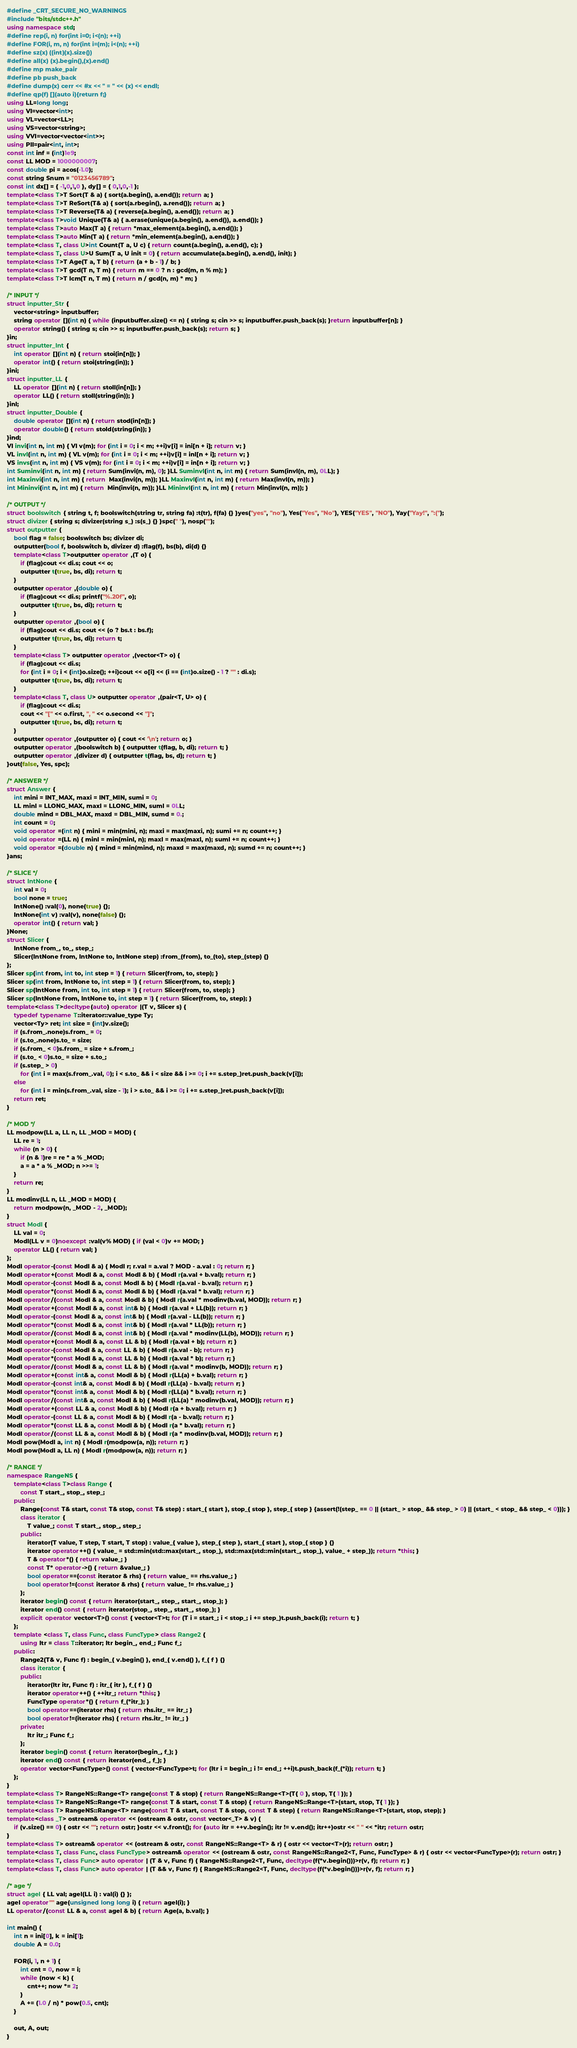<code> <loc_0><loc_0><loc_500><loc_500><_C++_>#define _CRT_SECURE_NO_WARNINGS
#include "bits/stdc++.h"
using namespace std;
#define rep(i, n) for(int i=0; i<(n); ++i)
#define FOR(i, m, n) for(int i=(m); i<(n); ++i)
#define sz(x) ((int)(x).size())
#define all(x) (x).begin(),(x).end()
#define mp make_pair
#define pb push_back
#define dump(x) cerr << #x << " = " << (x) << endl;
#define qp(f) [](auto i){return f;}
using LL=long long;
using VI=vector<int>;
using VL=vector<LL>;
using VS=vector<string>;
using VVI=vector<vector<int>>;
using PII=pair<int, int>;
const int inf = (int)1e9;
const LL MOD = 1000000007;
const double pi = acos(-1.0);
const string Snum = "0123456789";
const int dx[] = { -1,0,1,0 }, dy[] = { 0,1,0,-1 };
template<class T>T Sort(T & a) { sort(a.begin(), a.end()); return a; }
template<class T>T ReSort(T& a) { sort(a.rbegin(), a.rend()); return a; }
template<class T>T Reverse(T& a) { reverse(a.begin(), a.end()); return a; }
template<class T>void Unique(T& a) { a.erase(unique(a.begin(), a.end()), a.end()); }
template<class T>auto Max(T a) { return *max_element(a.begin(), a.end()); }
template<class T>auto Min(T a) { return *min_element(a.begin(), a.end()); }
template<class T, class U>int Count(T a, U c) { return count(a.begin(), a.end(), c); }
template<class T, class U>U Sum(T a, U init = 0) { return accumulate(a.begin(), a.end(), init); }
template<class T>T Age(T a, T b) { return (a + b - 1) / b; }
template<class T>T gcd(T n, T m) { return m == 0 ? n : gcd(m, n % m); }
template<class T>T lcm(T n, T m) { return n / gcd(n, m) * m; }

/* INPUT */
struct inputter_Str {
	vector<string> inputbuffer;
	string operator [](int n) { while (inputbuffer.size() <= n) { string s; cin >> s; inputbuffer.push_back(s); }return inputbuffer[n]; }
	operator string() { string s; cin >> s; inputbuffer.push_back(s); return s; }
}in;
struct inputter_Int {
	int operator [](int n) { return stoi(in[n]); }
	operator int() { return stoi(string(in)); }
}ini;
struct inputter_LL {
	LL operator [](int n) { return stoll(in[n]); }
	operator LL() { return stoll(string(in)); }
}inl;
struct inputter_Double {
	double operator [](int n) { return stod(in[n]); }
	operator double() { return stold(string(in)); }
}ind;
VI invi(int n, int m) { VI v(m); for (int i = 0; i < m; ++i)v[i] = ini[n + i]; return v; }
VL invl(int n, int m) { VL v(m); for (int i = 0; i < m; ++i)v[i] = inl[n + i]; return v; }
VS invs(int n, int m) { VS v(m); for (int i = 0; i < m; ++i)v[i] = in[n + i]; return v; }
int Suminvi(int n, int m) { return Sum(invi(n, m), 0); }LL Suminvl(int n, int m) { return Sum(invl(n, m), 0LL); }
int Maxinvi(int n, int m) { return  Max(invi(n, m)); }LL Maxinvl(int n, int m) { return Max(invl(n, m)); }
int Mininvi(int n, int m) { return  Min(invi(n, m)); }LL Mininvl(int n, int m) { return Min(invl(n, m)); }

/* OUTPUT */
struct boolswitch { string t, f; boolswitch(string tr, string fa) :t(tr), f(fa) {} }yes("yes", "no"), Yes("Yes", "No"), YES("YES", "NO"), Yay("Yay!", ":(");
struct divizer { string s; divizer(string s_) :s(s_) {} }spc(" "), nosp("");
struct outputter {
	bool flag = false; boolswitch bs; divizer di;
	outputter(bool f, boolswitch b, divizer d) :flag(f), bs(b), di(d) {}
	template<class T>outputter operator ,(T o) {
		if (flag)cout << di.s; cout << o;
		outputter t(true, bs, di); return t;
	}
	outputter operator ,(double o) {
		if (flag)cout << di.s; printf("%.20f", o);
		outputter t(true, bs, di); return t;
	}
	outputter operator ,(bool o) {
		if (flag)cout << di.s; cout << (o ? bs.t : bs.f);
		outputter t(true, bs, di); return t;
	}
	template<class T> outputter operator ,(vector<T> o) {
		if (flag)cout << di.s;
		for (int i = 0; i < (int)o.size(); ++i)cout << o[i] << (i == (int)o.size() - 1 ? "" : di.s);
		outputter t(true, bs, di); return t;
	}
	template<class T, class U> outputter operator ,(pair<T, U> o) {
		if (flag)cout << di.s;
		cout << "[" << o.first, ", " << o.second << "]";
		outputter t(true, bs, di); return t;
	}
	outputter operator ,(outputter o) { cout << '\n'; return o; }
	outputter operator ,(boolswitch b) { outputter t(flag, b, di); return t; }
	outputter operator ,(divizer d) { outputter t(flag, bs, d); return t; }
}out(false, Yes, spc);

/* ANSWER */
struct Answer {
	int mini = INT_MAX, maxi = INT_MIN, sumi = 0;
	LL minl = LLONG_MAX, maxl = LLONG_MIN, suml = 0LL;
	double mind = DBL_MAX, maxd = DBL_MIN, sumd = 0.;
	int count = 0;
	void operator =(int n) { mini = min(mini, n); maxi = max(maxi, n); sumi += n; count++; }
	void operator =(LL n) { minl = min(minl, n); maxl = max(maxl, n); suml += n; count++; }
	void operator =(double n) { mind = min(mind, n); maxd = max(maxd, n); sumd += n; count++; }
}ans;

/* SLICE */
struct IntNone {
	int val = 0;
	bool none = true;
	IntNone() :val(0), none(true) {};
	IntNone(int v) :val(v), none(false) {};
	operator int() { return val; }
}None;
struct Slicer {
	IntNone from_, to_, step_;
	Slicer(IntNone from, IntNone to, IntNone step) :from_(from), to_(to), step_(step) {}
};
Slicer sp(int from, int to, int step = 1) { return Slicer(from, to, step); }
Slicer sp(int from, IntNone to, int step = 1) { return Slicer(from, to, step); }
Slicer sp(IntNone from, int to, int step = 1) { return Slicer(from, to, step); }
Slicer sp(IntNone from, IntNone to, int step = 1) { return Slicer(from, to, step); }
template<class T>decltype(auto) operator |(T v, Slicer s) {
	typedef typename T::iterator::value_type Ty;
	vector<Ty> ret; int size = (int)v.size();
	if (s.from_.none)s.from_ = 0;
	if (s.to_.none)s.to_ = size;
	if (s.from_ < 0)s.from_ = size + s.from_;
	if (s.to_ < 0)s.to_ = size + s.to_;
	if (s.step_ > 0)
		for (int i = max(s.from_.val, 0); i < s.to_ && i < size && i >= 0; i += s.step_)ret.push_back(v[i]);
	else
		for (int i = min(s.from_.val, size - 1); i > s.to_ && i >= 0; i += s.step_)ret.push_back(v[i]);
	return ret;
}

/* MOD */
LL modpow(LL a, LL n, LL _MOD = MOD) {
	LL re = 1;
	while (n > 0) {
		if (n & 1)re = re * a % _MOD;
		a = a * a % _MOD; n >>= 1;
	}
	return re;
}
LL modinv(LL n, LL _MOD = MOD) {
	return modpow(n, _MOD - 2, _MOD);
}
struct Modl {
	LL val = 0;
	Modl(LL v = 0)noexcept :val(v% MOD) { if (val < 0)v += MOD; }
	operator LL() { return val; }
};
Modl operator-(const Modl & a) { Modl r; r.val = a.val ? MOD - a.val : 0; return r; }
Modl operator+(const Modl & a, const Modl & b) { Modl r(a.val + b.val); return r; }
Modl operator-(const Modl & a, const Modl & b) { Modl r(a.val - b.val); return r; }
Modl operator*(const Modl & a, const Modl & b) { Modl r(a.val * b.val); return r; }
Modl operator/(const Modl & a, const Modl & b) { Modl r(a.val * modinv(b.val, MOD)); return r; }
Modl operator+(const Modl & a, const int& b) { Modl r(a.val + LL(b)); return r; }
Modl operator-(const Modl & a, const int& b) { Modl r(a.val - LL(b)); return r; }
Modl operator*(const Modl & a, const int& b) { Modl r(a.val * LL(b)); return r; }
Modl operator/(const Modl & a, const int& b) { Modl r(a.val * modinv(LL(b), MOD)); return r; }
Modl operator+(const Modl & a, const LL & b) { Modl r(a.val + b); return r; }
Modl operator-(const Modl & a, const LL & b) { Modl r(a.val - b); return r; }
Modl operator*(const Modl & a, const LL & b) { Modl r(a.val * b); return r; }
Modl operator/(const Modl & a, const LL & b) { Modl r(a.val * modinv(b, MOD)); return r; }
Modl operator+(const int& a, const Modl & b) { Modl r(LL(a) + b.val); return r; }
Modl operator-(const int& a, const Modl & b) { Modl r(LL(a) - b.val); return r; }
Modl operator*(const int& a, const Modl & b) { Modl r(LL(a) * b.val); return r; }
Modl operator/(const int& a, const Modl & b) { Modl r(LL(a) * modinv(b.val, MOD)); return r; }
Modl operator+(const LL & a, const Modl & b) { Modl r(a + b.val); return r; }
Modl operator-(const LL & a, const Modl & b) { Modl r(a - b.val); return r; }
Modl operator*(const LL & a, const Modl & b) { Modl r(a * b.val); return r; }
Modl operator/(const LL & a, const Modl & b) { Modl r(a * modinv(b.val, MOD)); return r; }
Modl pow(Modl a, int n) { Modl r(modpow(a, n)); return r; }
Modl pow(Modl a, LL n) { Modl r(modpow(a, n)); return r; }

/* RANGE */
namespace RangeNS {
	template<class T>class Range {
		const T start_, stop_, step_;
	public:
		Range(const T& start, const T& stop, const T& step) : start_{ start }, stop_{ stop }, step_{ step } {assert(!(step_ == 0 || (start_ > stop_ && step_ > 0) || (start_ < stop_ && step_ < 0))); }
		class iterator {
			T value_; const T start_, stop_, step_;
		public:
			iterator(T value, T step, T start, T stop) : value_{ value }, step_{ step }, start_{ start }, stop_{ stop } {}
			iterator operator++() { value_ = std::min(std::max(start_, stop_), std::max(std::min(start_, stop_), value_ + step_)); return *this; }
			T & operator*() { return value_; }
			const T* operator->() { return &value_; }
			bool operator==(const iterator & rhs) { return value_ == rhs.value_; }
			bool operator!=(const iterator & rhs) { return value_ != rhs.value_; }
		};
		iterator begin() const { return iterator(start_, step_, start_, stop_); }
		iterator end() const { return iterator(stop_, step_, start_, stop_); }
		explicit operator vector<T>() const { vector<T>t; for (T i = start_; i < stop_; i += step_)t.push_back(i); return t; }
	};
	template <class T, class Func, class FuncType> class Range2 {
		using Itr = class T::iterator; Itr begin_, end_; Func f_;
	public:
		Range2(T& v, Func f) : begin_{ v.begin() }, end_{ v.end() }, f_{ f } {}
		class iterator {
		public:
			iterator(Itr itr, Func f) : itr_{ itr }, f_{ f } {}
			iterator operator++() { ++itr_; return *this; }
			FuncType operator*() { return f_(*itr_); }
			bool operator==(iterator rhs) { return rhs.itr_ == itr_; }
			bool operator!=(iterator rhs) { return rhs.itr_ != itr_; }
		private:
			Itr itr_; Func f_;
		};
		iterator begin() const { return iterator(begin_, f_); }
		iterator end() const { return iterator(end_, f_); }
		operator vector<FuncType>() const { vector<FuncType>t; for (Itr i = begin_; i != end_; ++i)t.push_back(f_(*i)); return t; }
	};
}
template<class T> RangeNS::Range<T> range(const T & stop) { return RangeNS::Range<T>(T{ 0 }, stop, T{ 1 }); }
template<class T> RangeNS::Range<T> range(const T & start, const T & stop) { return RangeNS::Range<T>(start, stop, T{ 1 }); }
template<class T> RangeNS::Range<T> range(const T & start, const T & stop, const T & step) { return RangeNS::Range<T>(start, stop, step); }
template<class _T> ostream& operator << (ostream & ostr, const vector<_T> & v) {
	if (v.size() == 0) { ostr << ""; return ostr; }ostr << v.front(); for (auto itr = ++v.begin(); itr != v.end(); itr++)ostr << " " << *itr; return ostr;
}
template<class T> ostream& operator << (ostream & ostr, const RangeNS::Range<T> & r) { ostr << vector<T>(r); return ostr; }
template<class T, class Func, class FuncType> ostream& operator << (ostream & ostr, const RangeNS::Range2<T, Func, FuncType> & r) { ostr << vector<FuncType>(r); return ostr; }
template<class T, class Func> auto operator | (T & v, Func f) { RangeNS::Range2<T, Func, decltype(f(*v.begin()))>r(v, f); return r; }
template<class T, class Func> auto operator | (T && v, Func f) { RangeNS::Range2<T, Func, decltype(f(*v.begin()))>r(v, f); return r; }

/* age */
struct agel { LL val; agel(LL i) : val(i) {} };
agel operator"" age(unsigned long long i) { return agel(i); }
LL operator/(const LL & a, const agel & b) { return Age(a, b.val); }

int main() {
	int n = ini[0], k = ini[1];
	double A = 0.0;

	FOR(i, 1, n + 1) {
		int cnt = 0, now = i;
		while (now < k) {
			cnt++; now *= 2;
		}
		A += (1.0 / n) * pow(0.5, cnt);
	}

	out, A, out;
}</code> 